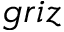<formula> <loc_0><loc_0><loc_500><loc_500>g r i z</formula> 